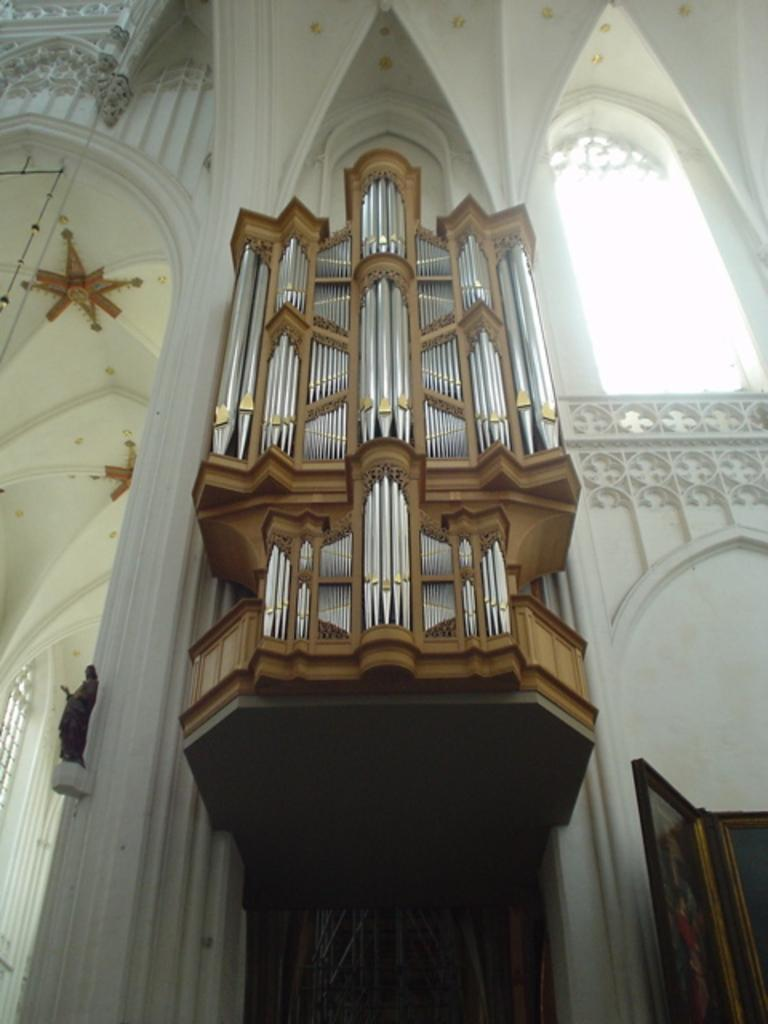What type of view is shown in the image? The image is an inner view. What can be seen inside the space in the image? There is a statue in the image. What type of badge is attached to the statue in the image? There is no badge present on the statue in the image. What type of material is the statue made of, and does it have any cracks or brass elements? The material and condition of the statue cannot be determined from the image alone. 